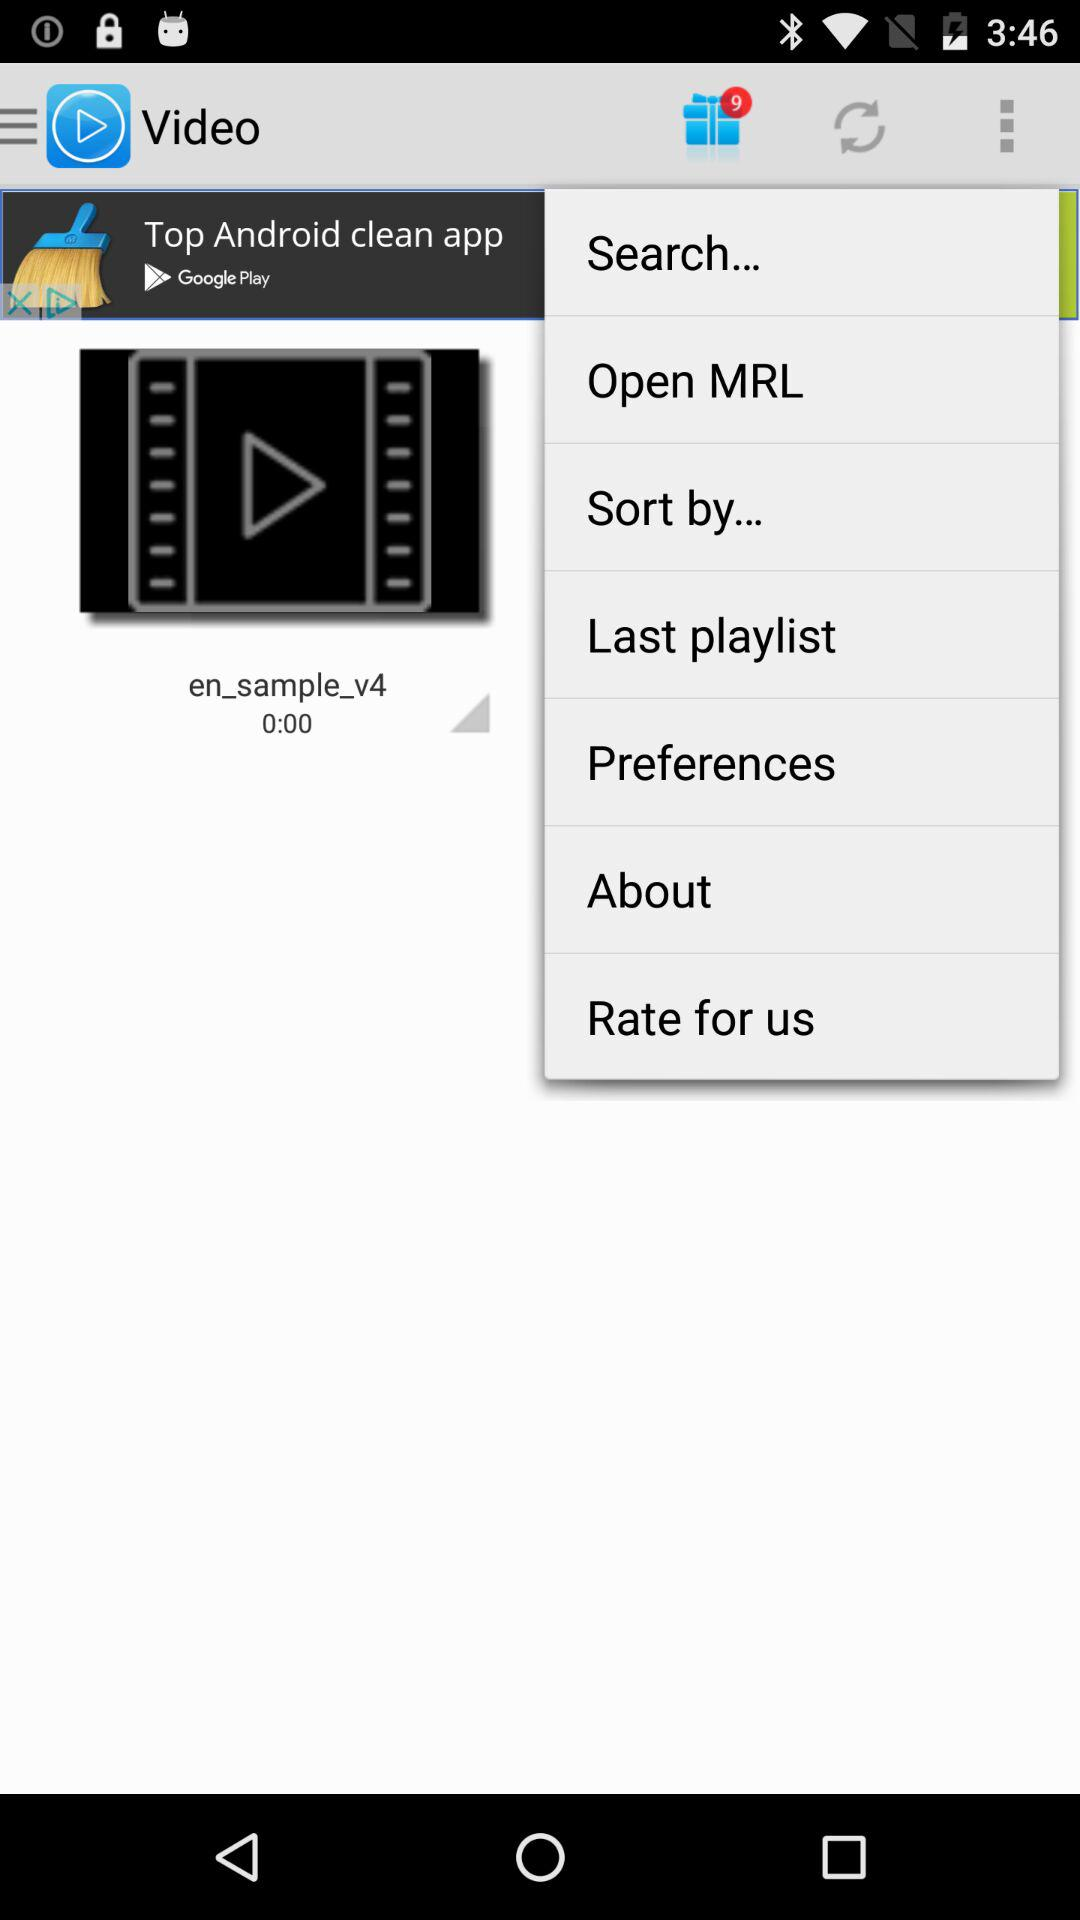Which option is selected in the drop-down menu?
When the provided information is insufficient, respond with <no answer>. <no answer> 